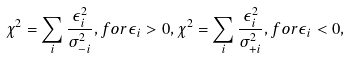Convert formula to latex. <formula><loc_0><loc_0><loc_500><loc_500>\chi ^ { 2 } = \sum _ { i } \frac { \epsilon _ { i } ^ { 2 } } { \sigma _ { - i } ^ { 2 } } , f o r \epsilon _ { i } > 0 , \chi ^ { 2 } = \sum _ { i } \frac { \epsilon _ { i } ^ { 2 } } { \sigma _ { + i } ^ { 2 } } , f o r \epsilon _ { i } < 0 ,</formula> 